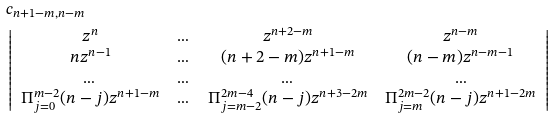Convert formula to latex. <formula><loc_0><loc_0><loc_500><loc_500>& c _ { n + 1 - m , n - m } \\ & \left | \begin{array} { c c c c } z ^ { n } & \dots & z ^ { n + 2 - m } & z ^ { n - m } \\ n z ^ { n - 1 } & \dots & ( n + 2 - m ) z ^ { n + 1 - m } & ( n - m ) z ^ { n - m - 1 } \\ \dots & \dots & \dots & \dots \\ \Pi _ { j = 0 } ^ { m - 2 } ( n - j ) z ^ { n + 1 - m } & \dots & \Pi _ { j = m - 2 } ^ { 2 m - 4 } ( n - j ) z ^ { n + 3 - 2 m } & \Pi _ { j = m } ^ { 2 m - 2 } ( n - j ) z ^ { n + 1 - 2 m } \end{array} \right |</formula> 